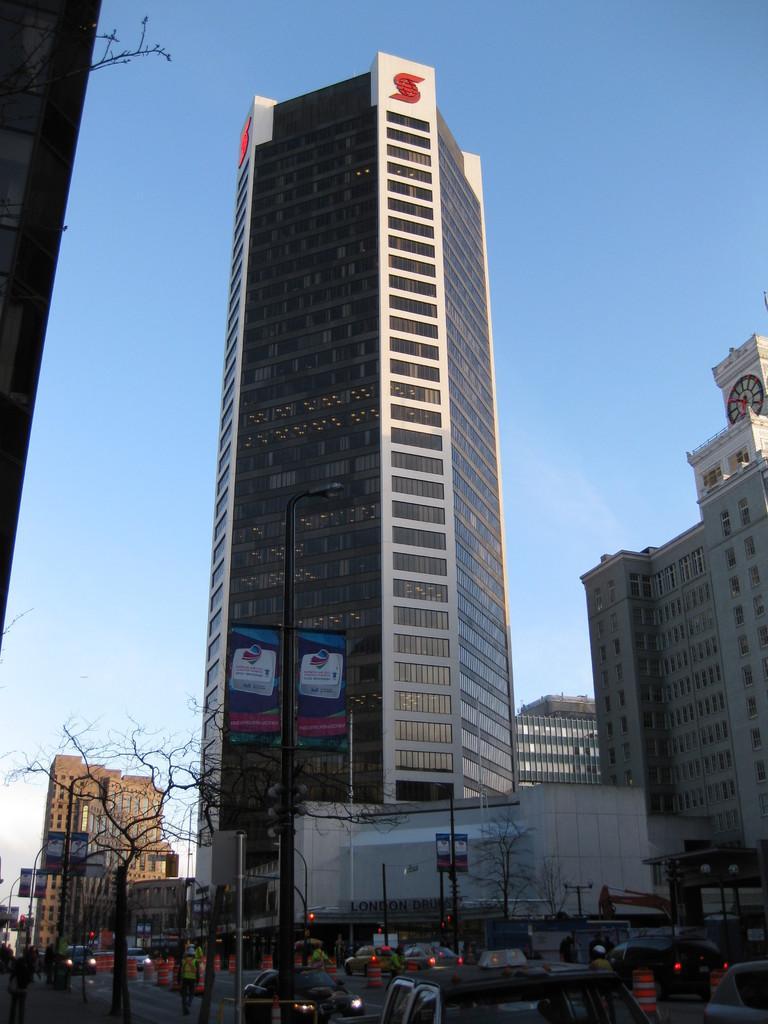Can you describe this image briefly? In this image there are many buildings, poles and also light poles. There are many vehicles on the road and also traffic cones. Hoardings are also visible in this image. At the top there is sky. Trees are also present. 